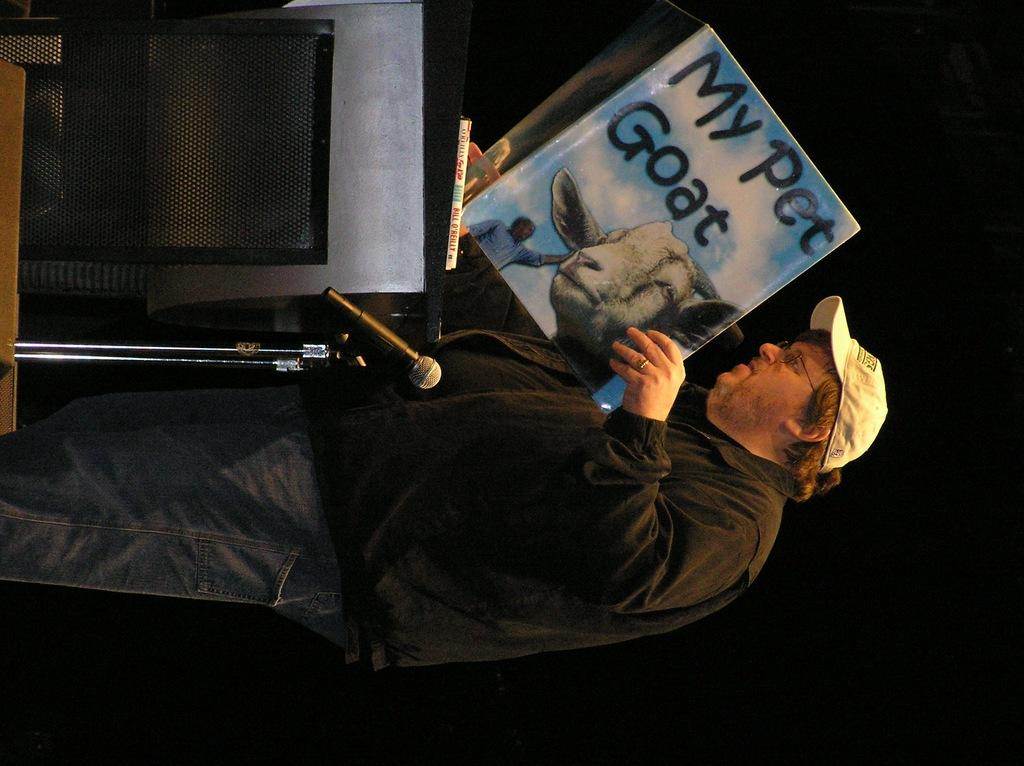Provide a one-sentence caption for the provided image. A man at a podium is holding up a My pet goat book. 